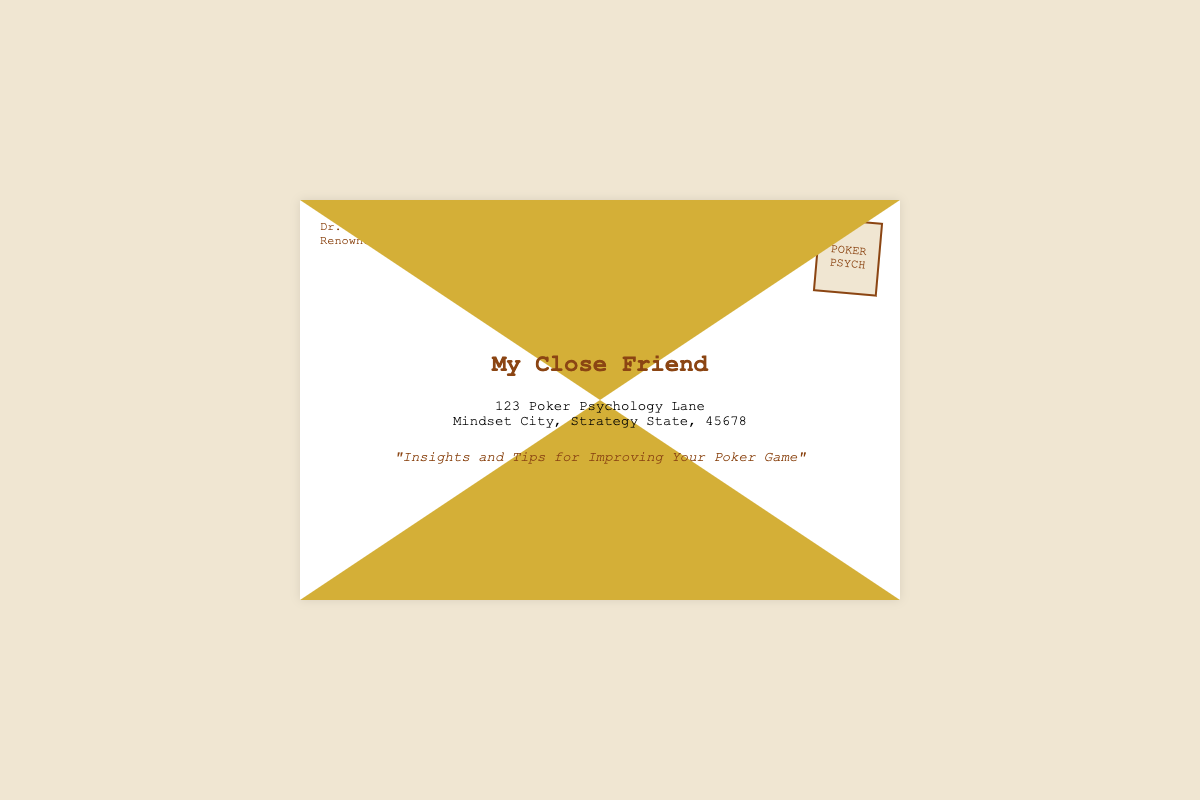What is the name of the sender? The sender's name is presented at the bottom left of the envelope, identifying who wrote the letter.
Answer: Dr. John Doe What is the title of the letter? The title appears prominently below the address and summarizes the content of the letter.
Answer: "Insights and Tips for Improving Your Poker Game" What is the address listed in the document? The address is found in the central part of the envelope, where the recipient's information is typically written.
Answer: 123 Poker Psychology Lane, Mindset City, Strategy State, 45678 What color is the stamp on the envelope? The color of the stamp is described based on its design and visual styling in the document.
Answer: Beige How many words are in the title of the letter? By counting each word in the title, one can find the total number.
Answer: 8 What is the primary purpose of the letter? The title suggests the central thematic focus of the contents of the letter, pointing towards guidance and improvement in a specific area.
Answer: Improvement What is the significance of the envelope's design? The design elements of the envelope, such as colors and shapes, convey a specific theme associated with poker psychology.
Answer: Aesthetic appeal What language is the document written in? The language can be inferred from the textual content found throughout the envelope.
Answer: English How many sections are there in the content of the envelope? The content can be visually divided into distinct parts, which may be categorized.
Answer: 3 